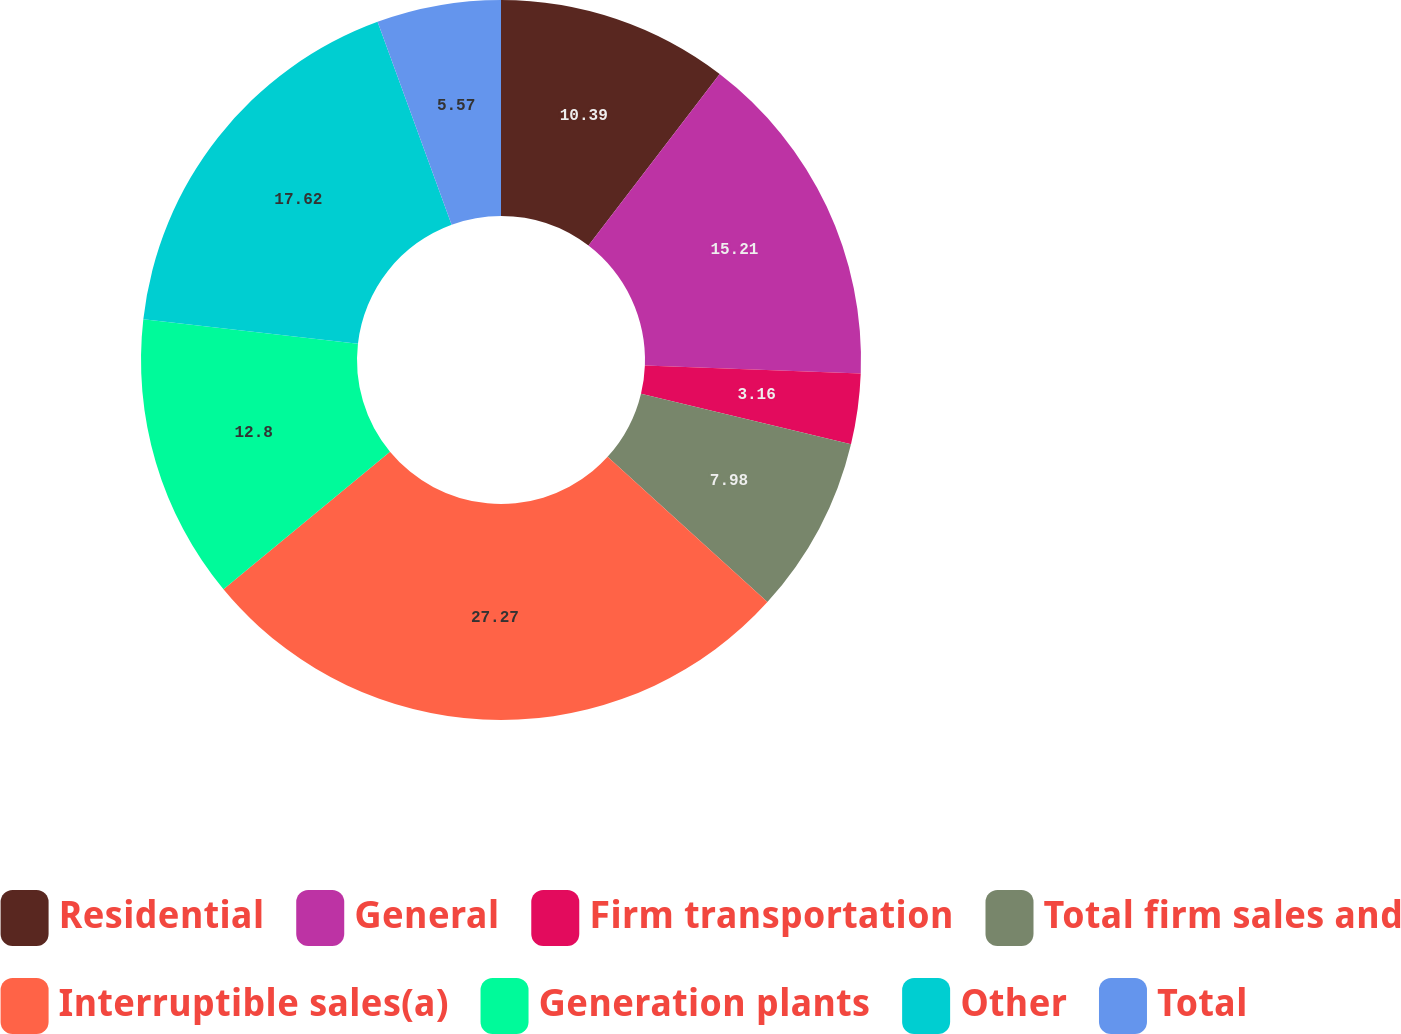<chart> <loc_0><loc_0><loc_500><loc_500><pie_chart><fcel>Residential<fcel>General<fcel>Firm transportation<fcel>Total firm sales and<fcel>Interruptible sales(a)<fcel>Generation plants<fcel>Other<fcel>Total<nl><fcel>10.39%<fcel>15.21%<fcel>3.16%<fcel>7.98%<fcel>27.27%<fcel>12.8%<fcel>17.62%<fcel>5.57%<nl></chart> 